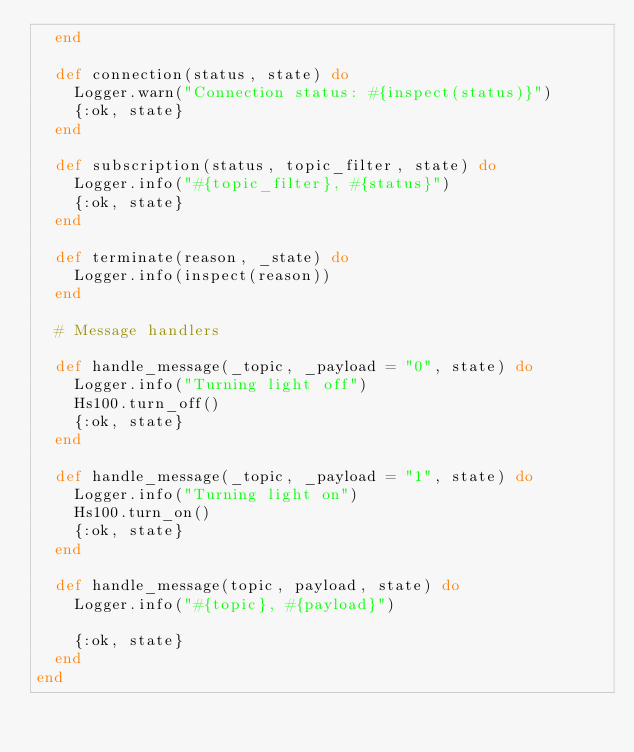Convert code to text. <code><loc_0><loc_0><loc_500><loc_500><_Elixir_>  end

  def connection(status, state) do
    Logger.warn("Connection status: #{inspect(status)}")
    {:ok, state}
  end

  def subscription(status, topic_filter, state) do
    Logger.info("#{topic_filter}, #{status}")
    {:ok, state}
  end

  def terminate(reason, _state) do
    Logger.info(inspect(reason))
  end

  # Message handlers

  def handle_message(_topic, _payload = "0", state) do
    Logger.info("Turning light off")
    Hs100.turn_off()
    {:ok, state}
  end

  def handle_message(_topic, _payload = "1", state) do
    Logger.info("Turning light on")
    Hs100.turn_on()
    {:ok, state}
  end

  def handle_message(topic, payload, state) do
    Logger.info("#{topic}, #{payload}")

    {:ok, state}
  end
end
</code> 